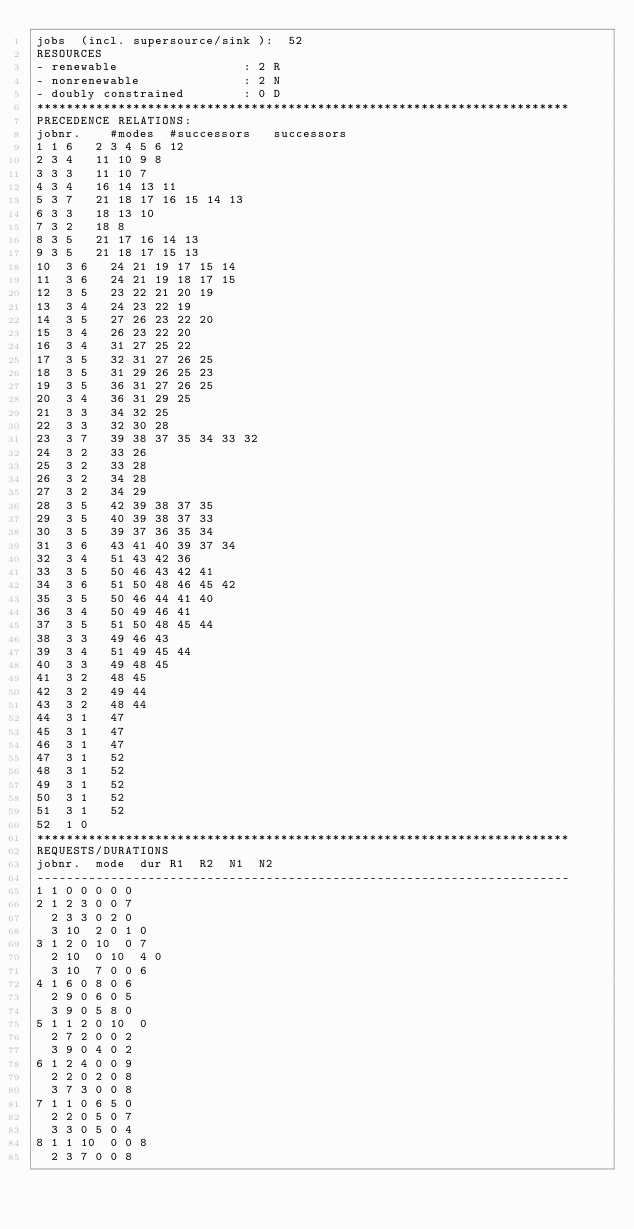<code> <loc_0><loc_0><loc_500><loc_500><_ObjectiveC_>jobs  (incl. supersource/sink ):	52
RESOURCES
- renewable                 : 2 R
- nonrenewable              : 2 N
- doubly constrained        : 0 D
************************************************************************
PRECEDENCE RELATIONS:
jobnr.    #modes  #successors   successors
1	1	6		2 3 4 5 6 12 
2	3	4		11 10 9 8 
3	3	3		11 10 7 
4	3	4		16 14 13 11 
5	3	7		21 18 17 16 15 14 13 
6	3	3		18 13 10 
7	3	2		18 8 
8	3	5		21 17 16 14 13 
9	3	5		21 18 17 15 13 
10	3	6		24 21 19 17 15 14 
11	3	6		24 21 19 18 17 15 
12	3	5		23 22 21 20 19 
13	3	4		24 23 22 19 
14	3	5		27 26 23 22 20 
15	3	4		26 23 22 20 
16	3	4		31 27 25 22 
17	3	5		32 31 27 26 25 
18	3	5		31 29 26 25 23 
19	3	5		36 31 27 26 25 
20	3	4		36 31 29 25 
21	3	3		34 32 25 
22	3	3		32 30 28 
23	3	7		39 38 37 35 34 33 32 
24	3	2		33 26 
25	3	2		33 28 
26	3	2		34 28 
27	3	2		34 29 
28	3	5		42 39 38 37 35 
29	3	5		40 39 38 37 33 
30	3	5		39 37 36 35 34 
31	3	6		43 41 40 39 37 34 
32	3	4		51 43 42 36 
33	3	5		50 46 43 42 41 
34	3	6		51 50 48 46 45 42 
35	3	5		50 46 44 41 40 
36	3	4		50 49 46 41 
37	3	5		51 50 48 45 44 
38	3	3		49 46 43 
39	3	4		51 49 45 44 
40	3	3		49 48 45 
41	3	2		48 45 
42	3	2		49 44 
43	3	2		48 44 
44	3	1		47 
45	3	1		47 
46	3	1		47 
47	3	1		52 
48	3	1		52 
49	3	1		52 
50	3	1		52 
51	3	1		52 
52	1	0		
************************************************************************
REQUESTS/DURATIONS
jobnr.	mode	dur	R1	R2	N1	N2	
------------------------------------------------------------------------
1	1	0	0	0	0	0	
2	1	2	3	0	0	7	
	2	3	3	0	2	0	
	3	10	2	0	1	0	
3	1	2	0	10	0	7	
	2	10	0	10	4	0	
	3	10	7	0	0	6	
4	1	6	0	8	0	6	
	2	9	0	6	0	5	
	3	9	0	5	8	0	
5	1	1	2	0	10	0	
	2	7	2	0	0	2	
	3	9	0	4	0	2	
6	1	2	4	0	0	9	
	2	2	0	2	0	8	
	3	7	3	0	0	8	
7	1	1	0	6	5	0	
	2	2	0	5	0	7	
	3	3	0	5	0	4	
8	1	1	10	0	0	8	
	2	3	7	0	0	8	</code> 